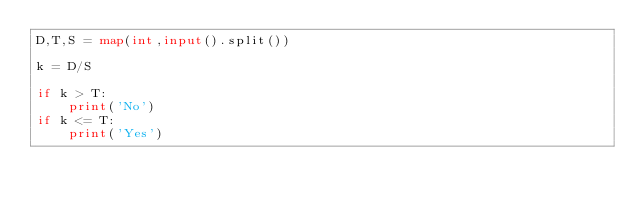<code> <loc_0><loc_0><loc_500><loc_500><_Python_>D,T,S = map(int,input().split())

k = D/S

if k > T:
    print('No')
if k <= T:
    print('Yes')</code> 